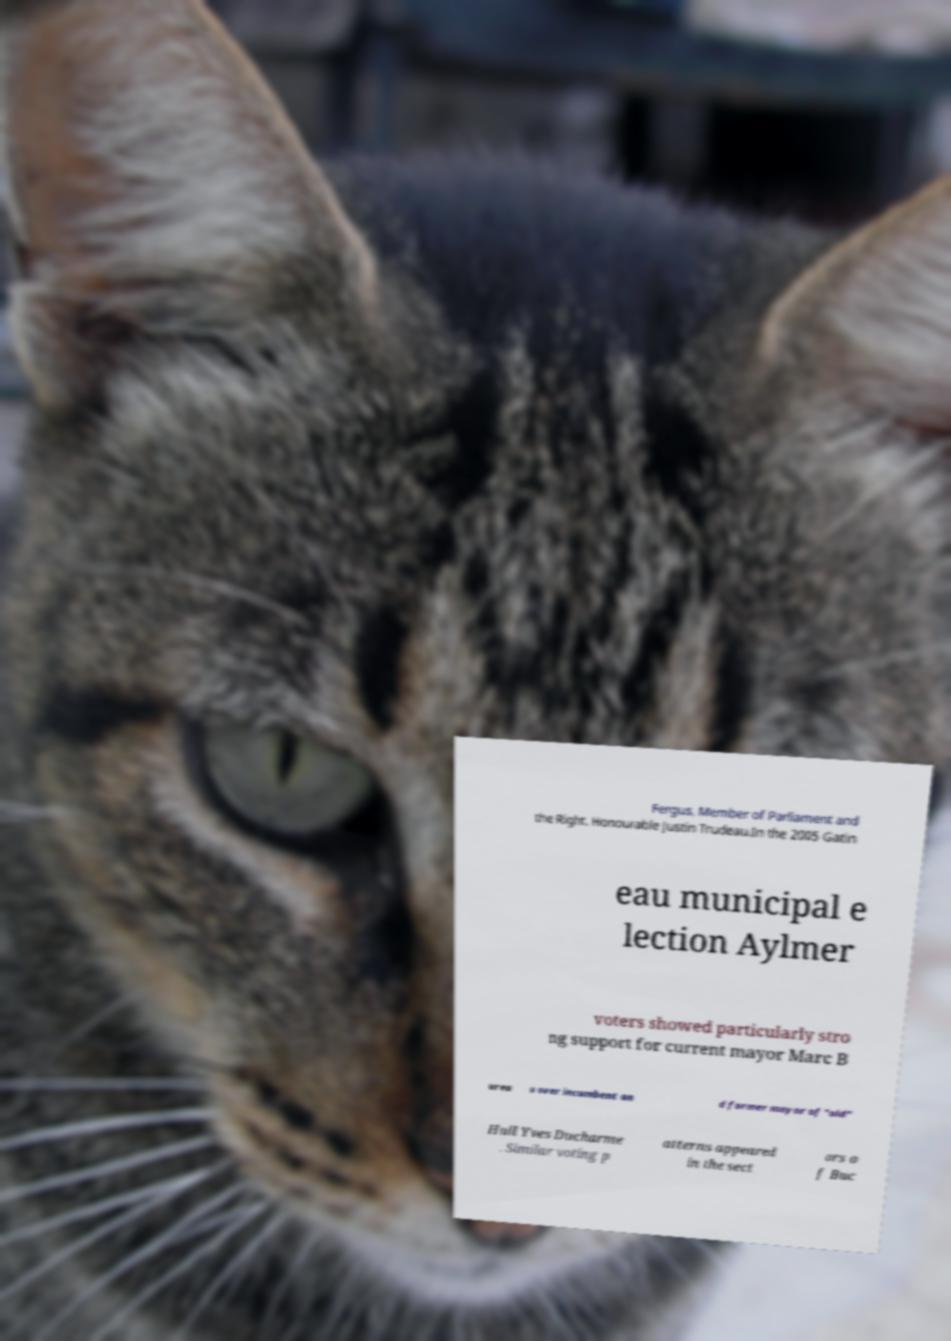Please read and relay the text visible in this image. What does it say? Fergus, Member of Parliament and the Right. Honourable Justin Trudeau.In the 2005 Gatin eau municipal e lection Aylmer voters showed particularly stro ng support for current mayor Marc B urea u over incumbent an d former mayor of "old" Hull Yves Ducharme . Similar voting p atterns appeared in the sect ors o f Buc 